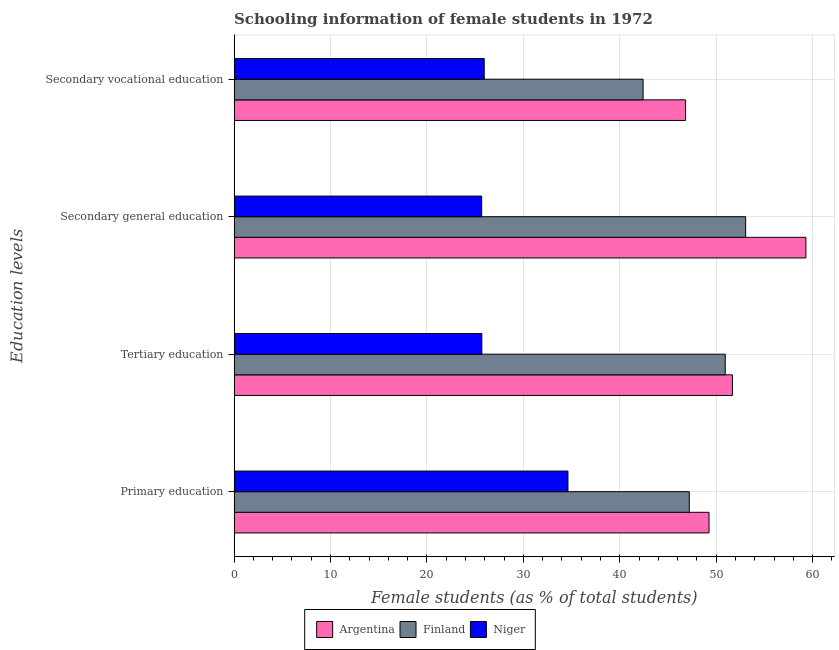How many different coloured bars are there?
Offer a very short reply. 3. Are the number of bars per tick equal to the number of legend labels?
Your answer should be compact. Yes. How many bars are there on the 4th tick from the bottom?
Provide a short and direct response. 3. What is the percentage of female students in primary education in Niger?
Your response must be concise. 34.62. Across all countries, what is the maximum percentage of female students in secondary vocational education?
Offer a very short reply. 46.82. Across all countries, what is the minimum percentage of female students in secondary vocational education?
Provide a short and direct response. 25.94. In which country was the percentage of female students in secondary education minimum?
Offer a very short reply. Niger. What is the total percentage of female students in tertiary education in the graph?
Make the answer very short. 128.31. What is the difference between the percentage of female students in secondary vocational education in Finland and that in Niger?
Provide a short and direct response. 16.48. What is the difference between the percentage of female students in secondary education in Argentina and the percentage of female students in primary education in Niger?
Provide a succinct answer. 24.68. What is the average percentage of female students in secondary education per country?
Ensure brevity in your answer.  46.01. What is the difference between the percentage of female students in secondary education and percentage of female students in secondary vocational education in Argentina?
Your answer should be compact. 12.48. What is the ratio of the percentage of female students in primary education in Finland to that in Niger?
Ensure brevity in your answer.  1.36. What is the difference between the highest and the second highest percentage of female students in primary education?
Your answer should be very brief. 2.05. What is the difference between the highest and the lowest percentage of female students in secondary education?
Keep it short and to the point. 33.63. In how many countries, is the percentage of female students in tertiary education greater than the average percentage of female students in tertiary education taken over all countries?
Provide a short and direct response. 2. What does the 1st bar from the top in Secondary general education represents?
Your answer should be compact. Niger. Is it the case that in every country, the sum of the percentage of female students in primary education and percentage of female students in tertiary education is greater than the percentage of female students in secondary education?
Make the answer very short. Yes. Are all the bars in the graph horizontal?
Keep it short and to the point. Yes. Does the graph contain grids?
Provide a short and direct response. Yes. What is the title of the graph?
Provide a succinct answer. Schooling information of female students in 1972. Does "Lao PDR" appear as one of the legend labels in the graph?
Your answer should be very brief. No. What is the label or title of the X-axis?
Your answer should be very brief. Female students (as % of total students). What is the label or title of the Y-axis?
Your response must be concise. Education levels. What is the Female students (as % of total students) of Argentina in Primary education?
Ensure brevity in your answer.  49.25. What is the Female students (as % of total students) in Finland in Primary education?
Offer a terse response. 47.21. What is the Female students (as % of total students) of Niger in Primary education?
Offer a very short reply. 34.62. What is the Female students (as % of total students) of Argentina in Tertiary education?
Provide a short and direct response. 51.68. What is the Female students (as % of total students) of Finland in Tertiary education?
Give a very brief answer. 50.94. What is the Female students (as % of total students) of Niger in Tertiary education?
Give a very brief answer. 25.69. What is the Female students (as % of total students) of Argentina in Secondary general education?
Make the answer very short. 59.3. What is the Female students (as % of total students) in Finland in Secondary general education?
Offer a terse response. 53.05. What is the Female students (as % of total students) of Niger in Secondary general education?
Offer a very short reply. 25.67. What is the Female students (as % of total students) of Argentina in Secondary vocational education?
Ensure brevity in your answer.  46.82. What is the Female students (as % of total students) in Finland in Secondary vocational education?
Provide a short and direct response. 42.42. What is the Female students (as % of total students) of Niger in Secondary vocational education?
Offer a terse response. 25.94. Across all Education levels, what is the maximum Female students (as % of total students) of Argentina?
Ensure brevity in your answer.  59.3. Across all Education levels, what is the maximum Female students (as % of total students) in Finland?
Keep it short and to the point. 53.05. Across all Education levels, what is the maximum Female students (as % of total students) of Niger?
Provide a succinct answer. 34.62. Across all Education levels, what is the minimum Female students (as % of total students) in Argentina?
Give a very brief answer. 46.82. Across all Education levels, what is the minimum Female students (as % of total students) in Finland?
Give a very brief answer. 42.42. Across all Education levels, what is the minimum Female students (as % of total students) of Niger?
Your answer should be compact. 25.67. What is the total Female students (as % of total students) in Argentina in the graph?
Give a very brief answer. 207.06. What is the total Female students (as % of total students) of Finland in the graph?
Give a very brief answer. 193.61. What is the total Female students (as % of total students) in Niger in the graph?
Ensure brevity in your answer.  111.93. What is the difference between the Female students (as % of total students) in Argentina in Primary education and that in Tertiary education?
Keep it short and to the point. -2.43. What is the difference between the Female students (as % of total students) in Finland in Primary education and that in Tertiary education?
Ensure brevity in your answer.  -3.73. What is the difference between the Female students (as % of total students) of Niger in Primary education and that in Tertiary education?
Provide a succinct answer. 8.93. What is the difference between the Female students (as % of total students) of Argentina in Primary education and that in Secondary general education?
Make the answer very short. -10.05. What is the difference between the Female students (as % of total students) of Finland in Primary education and that in Secondary general education?
Your answer should be compact. -5.85. What is the difference between the Female students (as % of total students) of Niger in Primary education and that in Secondary general education?
Offer a very short reply. 8.95. What is the difference between the Female students (as % of total students) in Argentina in Primary education and that in Secondary vocational education?
Your response must be concise. 2.43. What is the difference between the Female students (as % of total students) of Finland in Primary education and that in Secondary vocational education?
Give a very brief answer. 4.79. What is the difference between the Female students (as % of total students) in Niger in Primary education and that in Secondary vocational education?
Give a very brief answer. 8.68. What is the difference between the Female students (as % of total students) of Argentina in Tertiary education and that in Secondary general education?
Provide a short and direct response. -7.62. What is the difference between the Female students (as % of total students) of Finland in Tertiary education and that in Secondary general education?
Your answer should be very brief. -2.12. What is the difference between the Female students (as % of total students) of Niger in Tertiary education and that in Secondary general education?
Your response must be concise. 0.02. What is the difference between the Female students (as % of total students) in Argentina in Tertiary education and that in Secondary vocational education?
Make the answer very short. 4.86. What is the difference between the Female students (as % of total students) of Finland in Tertiary education and that in Secondary vocational education?
Your answer should be compact. 8.52. What is the difference between the Female students (as % of total students) of Niger in Tertiary education and that in Secondary vocational education?
Offer a very short reply. -0.25. What is the difference between the Female students (as % of total students) in Argentina in Secondary general education and that in Secondary vocational education?
Your answer should be compact. 12.48. What is the difference between the Female students (as % of total students) of Finland in Secondary general education and that in Secondary vocational education?
Ensure brevity in your answer.  10.64. What is the difference between the Female students (as % of total students) of Niger in Secondary general education and that in Secondary vocational education?
Your answer should be very brief. -0.27. What is the difference between the Female students (as % of total students) in Argentina in Primary education and the Female students (as % of total students) in Finland in Tertiary education?
Offer a terse response. -1.68. What is the difference between the Female students (as % of total students) of Argentina in Primary education and the Female students (as % of total students) of Niger in Tertiary education?
Provide a succinct answer. 23.56. What is the difference between the Female students (as % of total students) of Finland in Primary education and the Female students (as % of total students) of Niger in Tertiary education?
Provide a succinct answer. 21.51. What is the difference between the Female students (as % of total students) of Argentina in Primary education and the Female students (as % of total students) of Finland in Secondary general education?
Your answer should be compact. -3.8. What is the difference between the Female students (as % of total students) in Argentina in Primary education and the Female students (as % of total students) in Niger in Secondary general education?
Keep it short and to the point. 23.58. What is the difference between the Female students (as % of total students) in Finland in Primary education and the Female students (as % of total students) in Niger in Secondary general education?
Offer a very short reply. 21.53. What is the difference between the Female students (as % of total students) in Argentina in Primary education and the Female students (as % of total students) in Finland in Secondary vocational education?
Keep it short and to the point. 6.84. What is the difference between the Female students (as % of total students) of Argentina in Primary education and the Female students (as % of total students) of Niger in Secondary vocational education?
Provide a short and direct response. 23.32. What is the difference between the Female students (as % of total students) of Finland in Primary education and the Female students (as % of total students) of Niger in Secondary vocational education?
Provide a succinct answer. 21.27. What is the difference between the Female students (as % of total students) of Argentina in Tertiary education and the Female students (as % of total students) of Finland in Secondary general education?
Make the answer very short. -1.37. What is the difference between the Female students (as % of total students) in Argentina in Tertiary education and the Female students (as % of total students) in Niger in Secondary general education?
Your response must be concise. 26.01. What is the difference between the Female students (as % of total students) in Finland in Tertiary education and the Female students (as % of total students) in Niger in Secondary general education?
Your answer should be very brief. 25.26. What is the difference between the Female students (as % of total students) of Argentina in Tertiary education and the Female students (as % of total students) of Finland in Secondary vocational education?
Ensure brevity in your answer.  9.26. What is the difference between the Female students (as % of total students) of Argentina in Tertiary education and the Female students (as % of total students) of Niger in Secondary vocational education?
Your answer should be compact. 25.74. What is the difference between the Female students (as % of total students) in Finland in Tertiary education and the Female students (as % of total students) in Niger in Secondary vocational education?
Your answer should be very brief. 25. What is the difference between the Female students (as % of total students) in Argentina in Secondary general education and the Female students (as % of total students) in Finland in Secondary vocational education?
Offer a terse response. 16.89. What is the difference between the Female students (as % of total students) in Argentina in Secondary general education and the Female students (as % of total students) in Niger in Secondary vocational education?
Offer a very short reply. 33.36. What is the difference between the Female students (as % of total students) in Finland in Secondary general education and the Female students (as % of total students) in Niger in Secondary vocational education?
Make the answer very short. 27.11. What is the average Female students (as % of total students) of Argentina per Education levels?
Your answer should be very brief. 51.76. What is the average Female students (as % of total students) of Finland per Education levels?
Give a very brief answer. 48.4. What is the average Female students (as % of total students) in Niger per Education levels?
Provide a succinct answer. 27.98. What is the difference between the Female students (as % of total students) in Argentina and Female students (as % of total students) in Finland in Primary education?
Give a very brief answer. 2.05. What is the difference between the Female students (as % of total students) of Argentina and Female students (as % of total students) of Niger in Primary education?
Your answer should be very brief. 14.63. What is the difference between the Female students (as % of total students) of Finland and Female students (as % of total students) of Niger in Primary education?
Offer a very short reply. 12.58. What is the difference between the Female students (as % of total students) of Argentina and Female students (as % of total students) of Finland in Tertiary education?
Offer a very short reply. 0.74. What is the difference between the Female students (as % of total students) of Argentina and Female students (as % of total students) of Niger in Tertiary education?
Keep it short and to the point. 25.99. What is the difference between the Female students (as % of total students) in Finland and Female students (as % of total students) in Niger in Tertiary education?
Give a very brief answer. 25.24. What is the difference between the Female students (as % of total students) of Argentina and Female students (as % of total students) of Finland in Secondary general education?
Provide a succinct answer. 6.25. What is the difference between the Female students (as % of total students) in Argentina and Female students (as % of total students) in Niger in Secondary general education?
Offer a very short reply. 33.63. What is the difference between the Female students (as % of total students) in Finland and Female students (as % of total students) in Niger in Secondary general education?
Provide a short and direct response. 27.38. What is the difference between the Female students (as % of total students) of Argentina and Female students (as % of total students) of Finland in Secondary vocational education?
Offer a very short reply. 4.41. What is the difference between the Female students (as % of total students) in Argentina and Female students (as % of total students) in Niger in Secondary vocational education?
Offer a very short reply. 20.88. What is the difference between the Female students (as % of total students) in Finland and Female students (as % of total students) in Niger in Secondary vocational education?
Make the answer very short. 16.48. What is the ratio of the Female students (as % of total students) of Argentina in Primary education to that in Tertiary education?
Make the answer very short. 0.95. What is the ratio of the Female students (as % of total students) of Finland in Primary education to that in Tertiary education?
Keep it short and to the point. 0.93. What is the ratio of the Female students (as % of total students) of Niger in Primary education to that in Tertiary education?
Keep it short and to the point. 1.35. What is the ratio of the Female students (as % of total students) of Argentina in Primary education to that in Secondary general education?
Keep it short and to the point. 0.83. What is the ratio of the Female students (as % of total students) of Finland in Primary education to that in Secondary general education?
Give a very brief answer. 0.89. What is the ratio of the Female students (as % of total students) of Niger in Primary education to that in Secondary general education?
Ensure brevity in your answer.  1.35. What is the ratio of the Female students (as % of total students) of Argentina in Primary education to that in Secondary vocational education?
Keep it short and to the point. 1.05. What is the ratio of the Female students (as % of total students) in Finland in Primary education to that in Secondary vocational education?
Your response must be concise. 1.11. What is the ratio of the Female students (as % of total students) in Niger in Primary education to that in Secondary vocational education?
Provide a succinct answer. 1.33. What is the ratio of the Female students (as % of total students) in Argentina in Tertiary education to that in Secondary general education?
Provide a succinct answer. 0.87. What is the ratio of the Female students (as % of total students) of Finland in Tertiary education to that in Secondary general education?
Provide a succinct answer. 0.96. What is the ratio of the Female students (as % of total students) in Niger in Tertiary education to that in Secondary general education?
Offer a very short reply. 1. What is the ratio of the Female students (as % of total students) of Argentina in Tertiary education to that in Secondary vocational education?
Give a very brief answer. 1.1. What is the ratio of the Female students (as % of total students) in Finland in Tertiary education to that in Secondary vocational education?
Offer a terse response. 1.2. What is the ratio of the Female students (as % of total students) of Niger in Tertiary education to that in Secondary vocational education?
Your answer should be compact. 0.99. What is the ratio of the Female students (as % of total students) of Argentina in Secondary general education to that in Secondary vocational education?
Your response must be concise. 1.27. What is the ratio of the Female students (as % of total students) of Finland in Secondary general education to that in Secondary vocational education?
Keep it short and to the point. 1.25. What is the difference between the highest and the second highest Female students (as % of total students) in Argentina?
Keep it short and to the point. 7.62. What is the difference between the highest and the second highest Female students (as % of total students) of Finland?
Ensure brevity in your answer.  2.12. What is the difference between the highest and the second highest Female students (as % of total students) of Niger?
Offer a terse response. 8.68. What is the difference between the highest and the lowest Female students (as % of total students) of Argentina?
Offer a terse response. 12.48. What is the difference between the highest and the lowest Female students (as % of total students) of Finland?
Make the answer very short. 10.64. What is the difference between the highest and the lowest Female students (as % of total students) of Niger?
Your answer should be very brief. 8.95. 